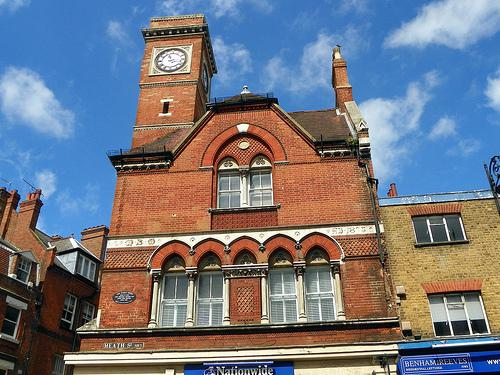Question: where was the picture taken?
Choices:
A. It was taken in the park.
B. It was taken in public.
C. It was taken near a building outside.
D. It was taken near the airport.
Answer with the letter. Answer: C Question: what does the sky look like?
Choices:
A. It looks clear and sunny.
B. It looks like a storm is forming.
C. It looks serene.
D. The sky looks blue and a little cloudy but it's nice.
Answer with the letter. Answer: D Question: how old does the building look?
Choices:
A. The building looks very old.
B. A hundred years old.
C. It looks like it was built in the 19th century.
D. It looks like it's been there longer than others.
Answer with the letter. Answer: A Question: what color is the building?
Choices:
A. Black.
B. Gray.
C. White.
D. The building is brown.
Answer with the letter. Answer: D Question: who is in the picture?
Choices:
A. A man.
B. Nobody is in the picture.
C. A woman.
D. A group of friends.
Answer with the letter. Answer: B Question: why did someone take this picture?
Choices:
A. To show how the building looks.
B. To capture the moment.
C. To send to a friend.
D. To examine later.
Answer with the letter. Answer: A 